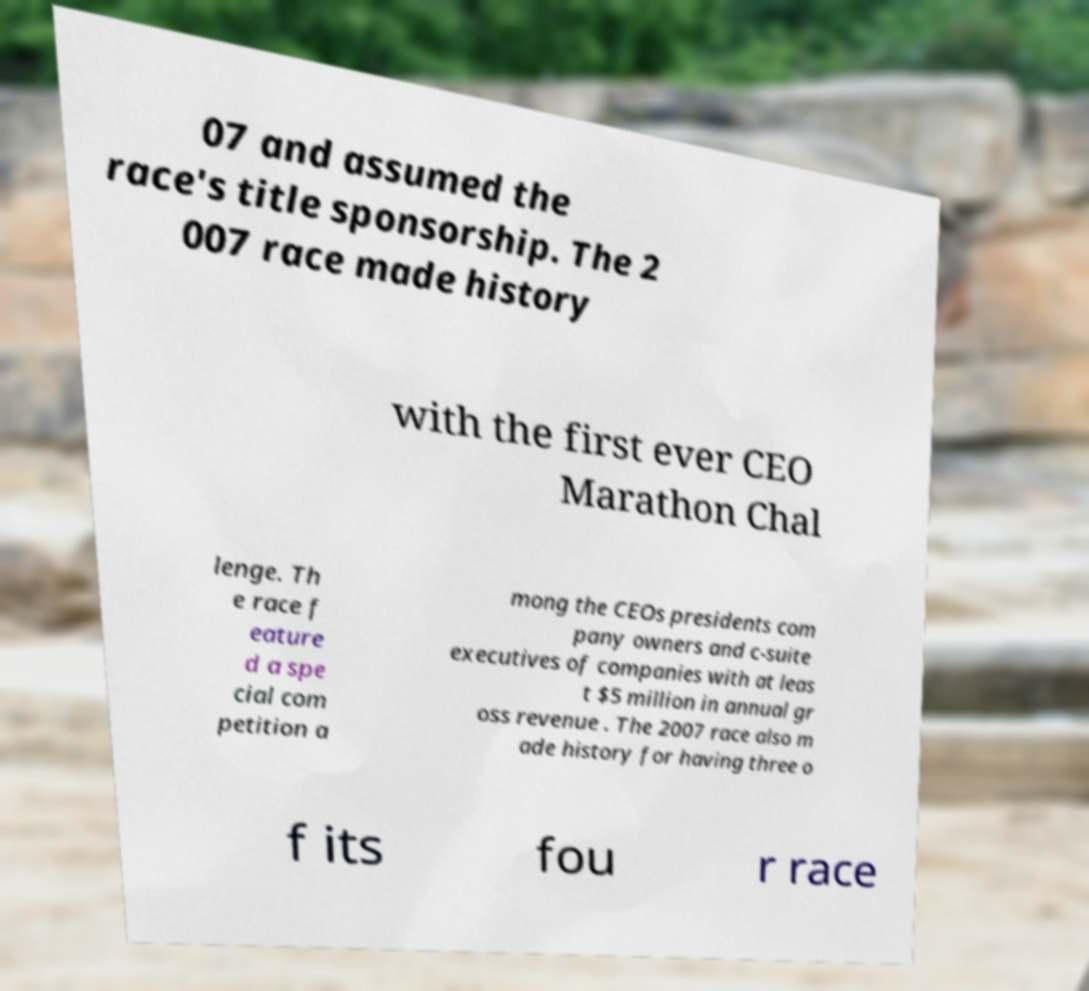What messages or text are displayed in this image? I need them in a readable, typed format. 07 and assumed the race's title sponsorship. The 2 007 race made history with the first ever CEO Marathon Chal lenge. Th e race f eature d a spe cial com petition a mong the CEOs presidents com pany owners and c-suite executives of companies with at leas t $5 million in annual gr oss revenue . The 2007 race also m ade history for having three o f its fou r race 